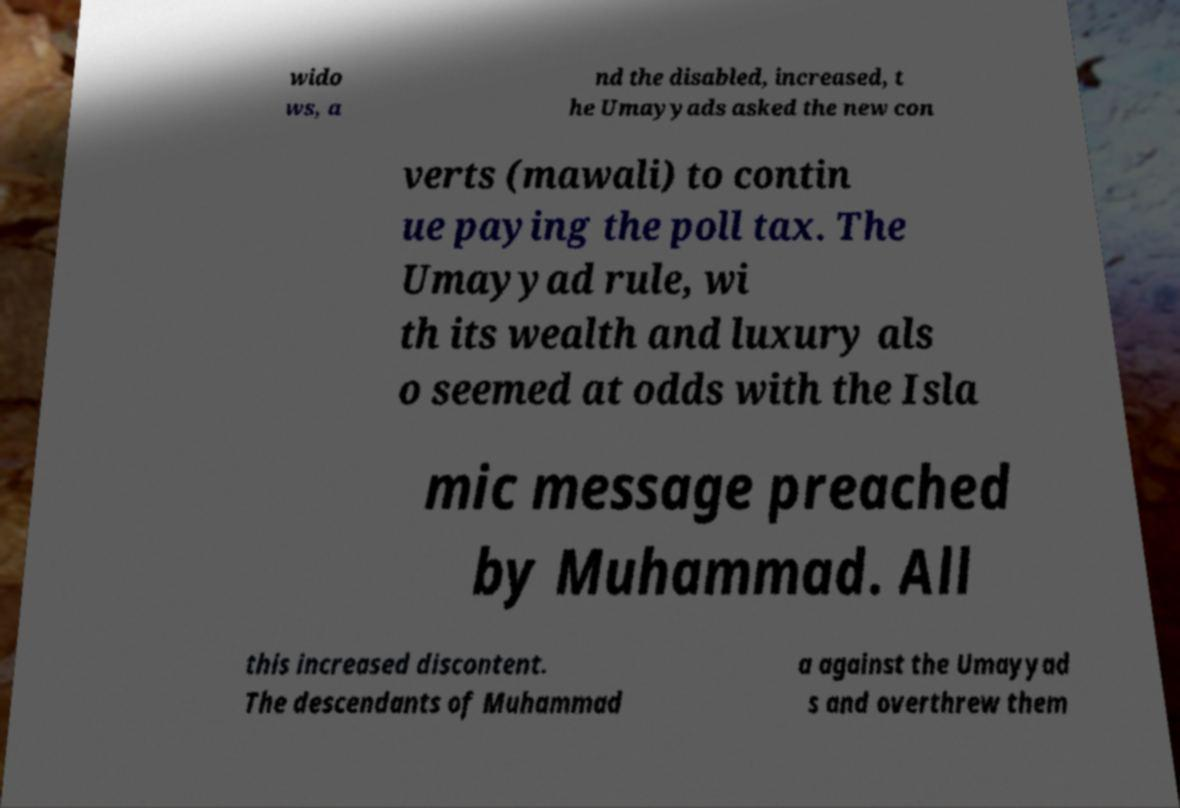Please identify and transcribe the text found in this image. wido ws, a nd the disabled, increased, t he Umayyads asked the new con verts (mawali) to contin ue paying the poll tax. The Umayyad rule, wi th its wealth and luxury als o seemed at odds with the Isla mic message preached by Muhammad. All this increased discontent. The descendants of Muhammad a against the Umayyad s and overthrew them 